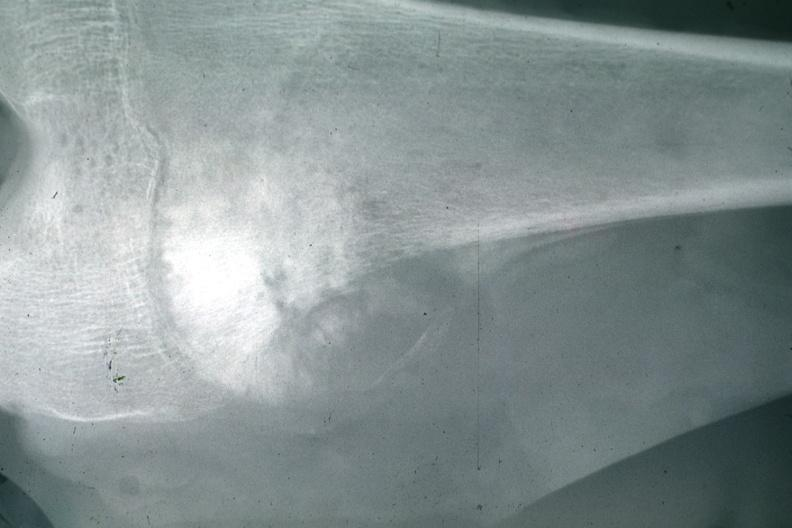s joints present?
Answer the question using a single word or phrase. Yes 